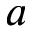<formula> <loc_0><loc_0><loc_500><loc_500>a</formula> 